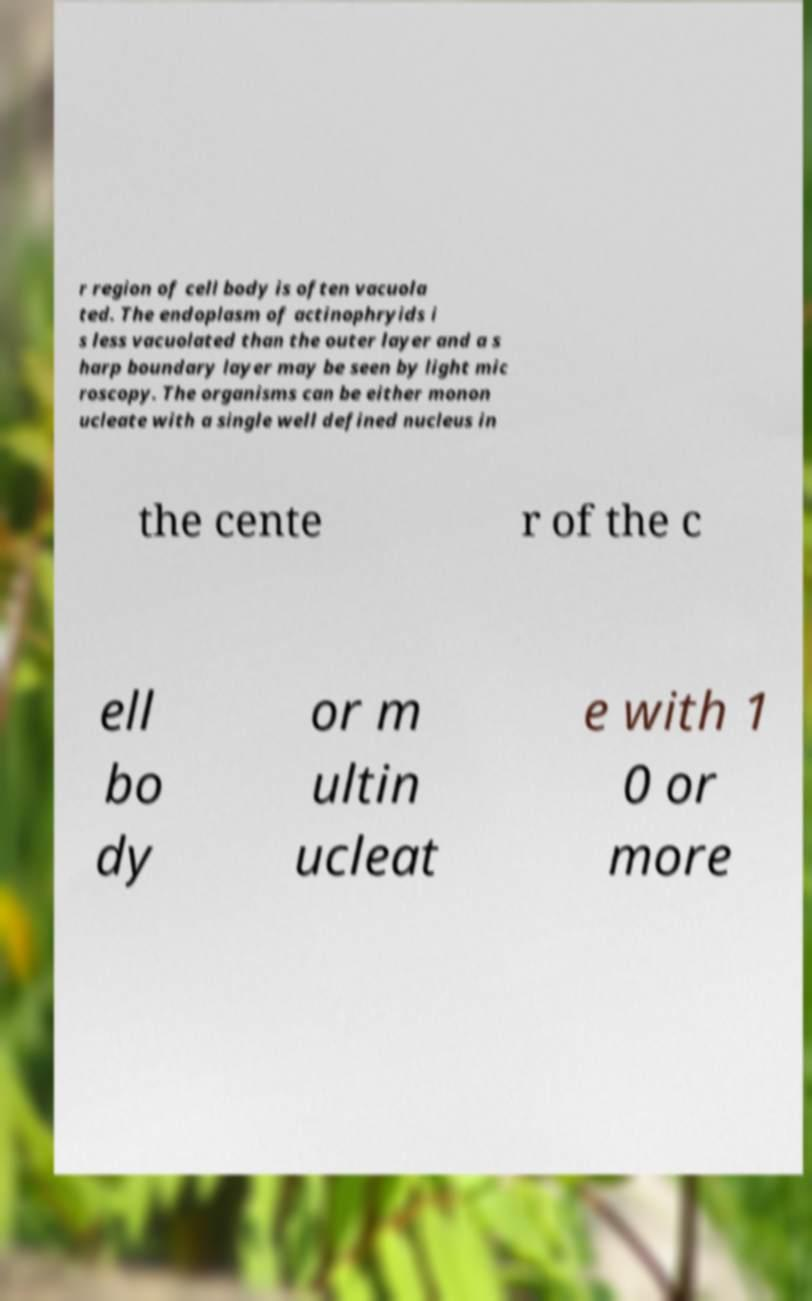There's text embedded in this image that I need extracted. Can you transcribe it verbatim? r region of cell body is often vacuola ted. The endoplasm of actinophryids i s less vacuolated than the outer layer and a s harp boundary layer may be seen by light mic roscopy. The organisms can be either monon ucleate with a single well defined nucleus in the cente r of the c ell bo dy or m ultin ucleat e with 1 0 or more 